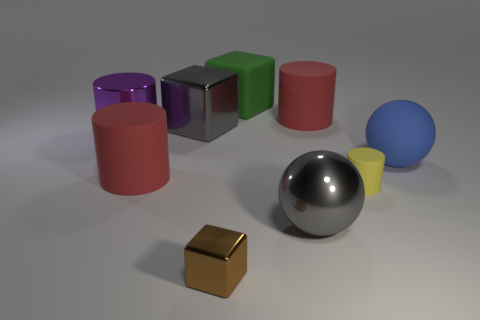Subtract all green cubes. How many red cylinders are left? 2 Subtract all small yellow matte cylinders. How many cylinders are left? 3 Subtract all purple cylinders. How many cylinders are left? 3 Add 1 green objects. How many objects exist? 10 Subtract all cylinders. How many objects are left? 5 Subtract all green cylinders. Subtract all green spheres. How many cylinders are left? 4 Subtract all large cyan objects. Subtract all big purple metal cylinders. How many objects are left? 8 Add 9 purple shiny cylinders. How many purple shiny cylinders are left? 10 Add 7 large blue balls. How many large blue balls exist? 8 Subtract 0 red blocks. How many objects are left? 9 